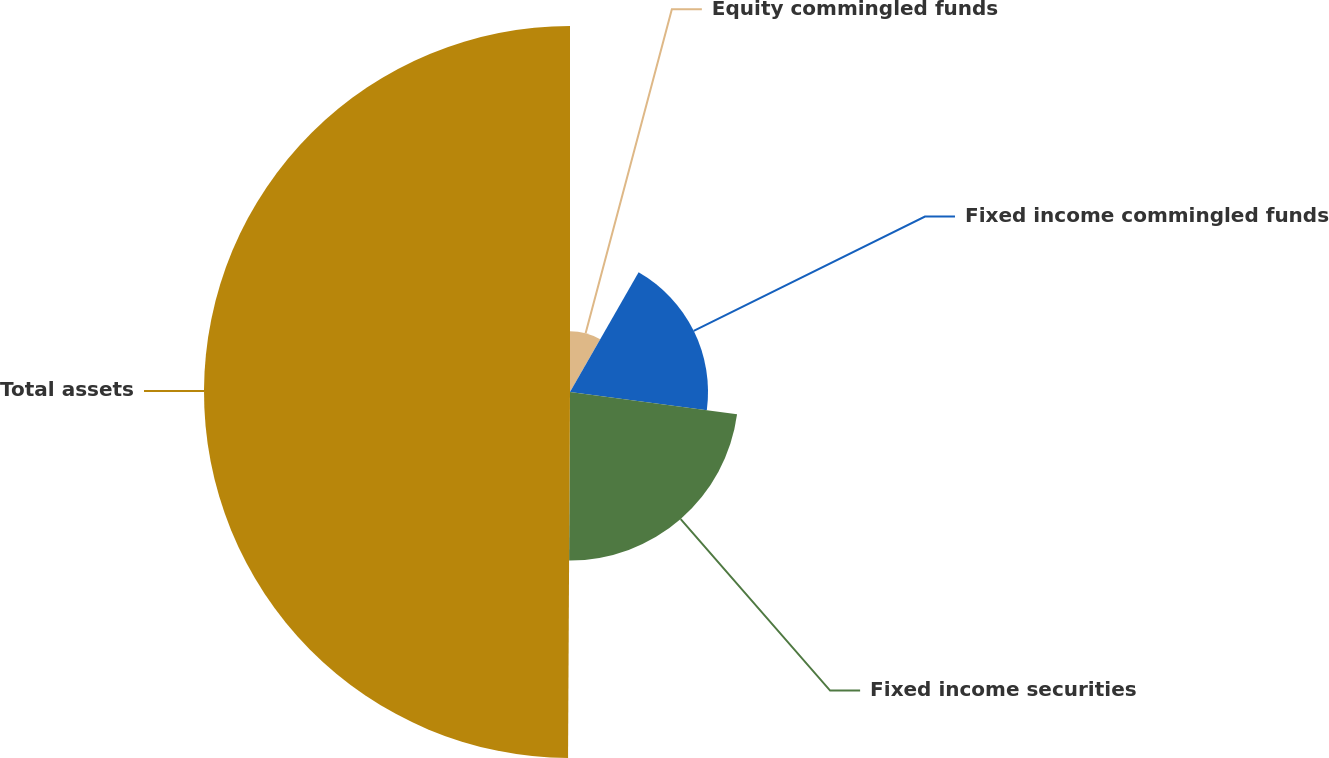Convert chart. <chart><loc_0><loc_0><loc_500><loc_500><pie_chart><fcel>Equity commingled funds<fcel>Fixed income commingled funds<fcel>Fixed income securities<fcel>Total assets<nl><fcel>8.28%<fcel>18.82%<fcel>22.98%<fcel>49.91%<nl></chart> 